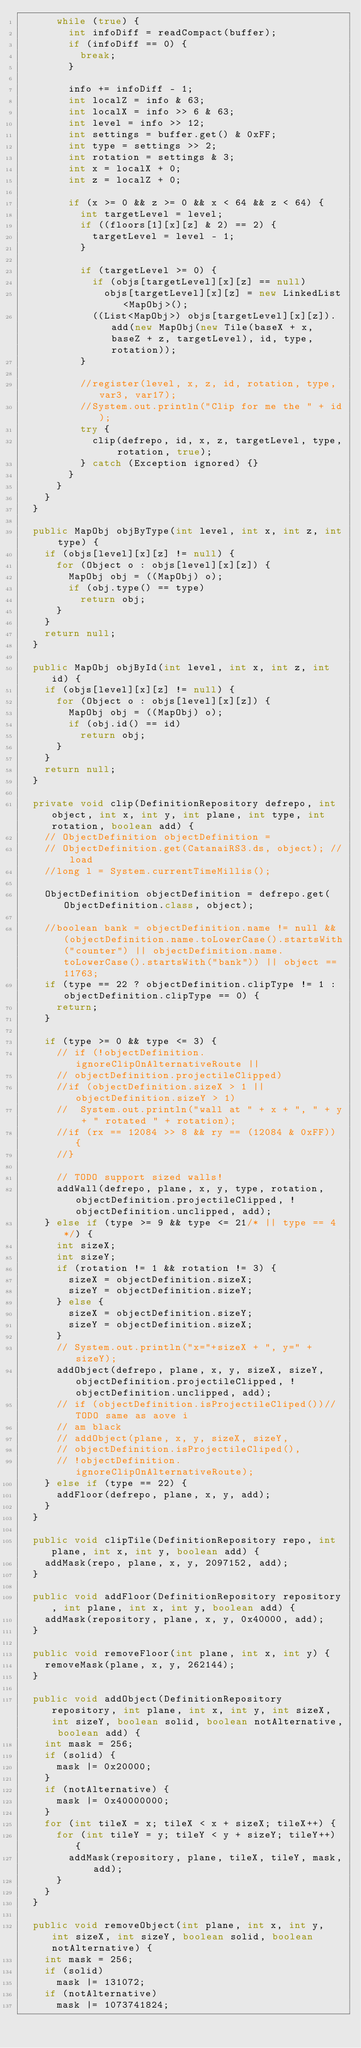<code> <loc_0><loc_0><loc_500><loc_500><_Java_>			while (true) {
				int infoDiff = readCompact(buffer);
				if (infoDiff == 0) {
					break;
				}

				info += infoDiff - 1;
				int localZ = info & 63;
				int localX = info >> 6 & 63;
				int level = info >> 12;
				int settings = buffer.get() & 0xFF;
				int type = settings >> 2;
				int rotation = settings & 3;
				int x = localX + 0;
				int z = localZ + 0;

				if (x >= 0 && z >= 0 && x < 64 && z < 64) {
					int targetLevel = level;
					if ((floors[1][x][z] & 2) == 2) {
						targetLevel = level - 1;
					}

					if (targetLevel >= 0) {
						if (objs[targetLevel][x][z] == null)
							objs[targetLevel][x][z] = new LinkedList<MapObj>();
						((List<MapObj>) objs[targetLevel][x][z]).add(new MapObj(new Tile(baseX + x, baseZ + z, targetLevel), id, type, rotation));
					}

					//register(level, x, z, id, rotation, type, var3, var17);
					//System.out.println("Clip for me the " + id);
					try {
						clip(defrepo, id, x, z, targetLevel, type, rotation, true);
					} catch (Exception ignored) {}
				}
			}
		}
	}

	public MapObj objByType(int level, int x, int z, int type) {
		if (objs[level][x][z] != null) {
			for (Object o : objs[level][x][z]) {
				MapObj obj = ((MapObj) o);
				if (obj.type() == type)
					return obj;
			}
		}
		return null;
	}

	public MapObj objById(int level, int x, int z, int id) {
		if (objs[level][x][z] != null) {
			for (Object o : objs[level][x][z]) {
				MapObj obj = ((MapObj) o);
				if (obj.id() == id)
					return obj;
			}
		}
		return null;
	}

	private void clip(DefinitionRepository defrepo, int object, int x, int y, int plane, int type, int rotation, boolean add) {
		// ObjectDefinition objectDefinition =
		// ObjectDefinition.get(CatanaiRS3.ds, object); // load
		//long l = System.currentTimeMillis();

		ObjectDefinition objectDefinition = defrepo.get(ObjectDefinition.class, object);

		//boolean bank = objectDefinition.name != null && (objectDefinition.name.toLowerCase().startsWith("counter") || objectDefinition.name.toLowerCase().startsWith("bank")) || object == 11763;
		if (type == 22 ? objectDefinition.clipType != 1 : objectDefinition.clipType == 0) {
			return;
		}

		if (type >= 0 && type <= 3) {
			// if (!objectDefinition.ignoreClipOnAlternativeRoute ||
			// objectDefinition.projectileClipped)
			//if (objectDefinition.sizeX > 1 || objectDefinition.sizeY > 1)
			//	System.out.println("wall at " + x + ", " + y + " rotated " + rotation);
			//if (rx == 12084 >> 8 && ry == (12084 & 0xFF)) {
			//}

			// TODO support sized walls!
			addWall(defrepo, plane, x, y, type, rotation, objectDefinition.projectileClipped, !objectDefinition.unclipped, add);
		} else if (type >= 9 && type <= 21/* || type == 4 */) {
			int sizeX;
			int sizeY;
			if (rotation != 1 && rotation != 3) {
				sizeX = objectDefinition.sizeX;
				sizeY = objectDefinition.sizeY;
			} else {
				sizeX = objectDefinition.sizeY;
				sizeY = objectDefinition.sizeX;
			}
			// System.out.println("x="+sizeX + ", y=" + sizeY);
			addObject(defrepo, plane, x, y, sizeX, sizeY, objectDefinition.projectileClipped, !objectDefinition.unclipped, add);
			// if (objectDefinition.isProjectileCliped())// TODO same as aove i
			// am black
			// addObject(plane, x, y, sizeX, sizeY,
			// objectDefinition.isProjectileCliped(),
			// !objectDefinition.ignoreClipOnAlternativeRoute);
		} else if (type == 22) {
			addFloor(defrepo, plane, x, y, add);
		}
	}

	public void clipTile(DefinitionRepository repo, int plane, int x, int y, boolean add) {
		addMask(repo, plane, x, y, 2097152, add);
	}

	public void addFloor(DefinitionRepository repository, int plane, int x, int y, boolean add) {
		addMask(repository, plane, x, y, 0x40000, add);
	}

	public void removeFloor(int plane, int x, int y) {
		removeMask(plane, x, y, 262144);
	}

	public void addObject(DefinitionRepository repository, int plane, int x, int y, int sizeX, int sizeY, boolean solid, boolean notAlternative, boolean add) {
		int mask = 256;
		if (solid) {
			mask |= 0x20000;
		}
		if (notAlternative) {
			mask |= 0x40000000;
		}
		for (int tileX = x; tileX < x + sizeX; tileX++) {
			for (int tileY = y; tileY < y + sizeY; tileY++) {
				addMask(repository, plane, tileX, tileY, mask, add);
			}
		}
	}

	public void removeObject(int plane, int x, int y, int sizeX, int sizeY, boolean solid, boolean notAlternative) {
		int mask = 256;
		if (solid)
			mask |= 131072;
		if (notAlternative)
			mask |= 1073741824;</code> 